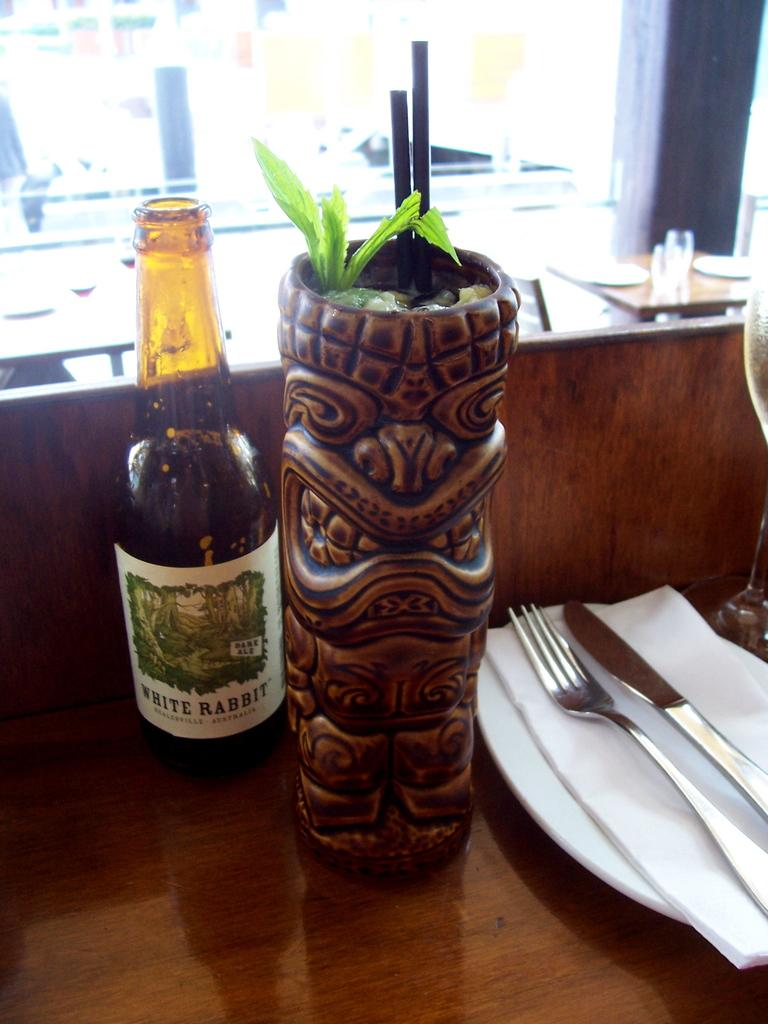<image>
Write a terse but informative summary of the picture. The type of drink in the bottle is White Rabbit 